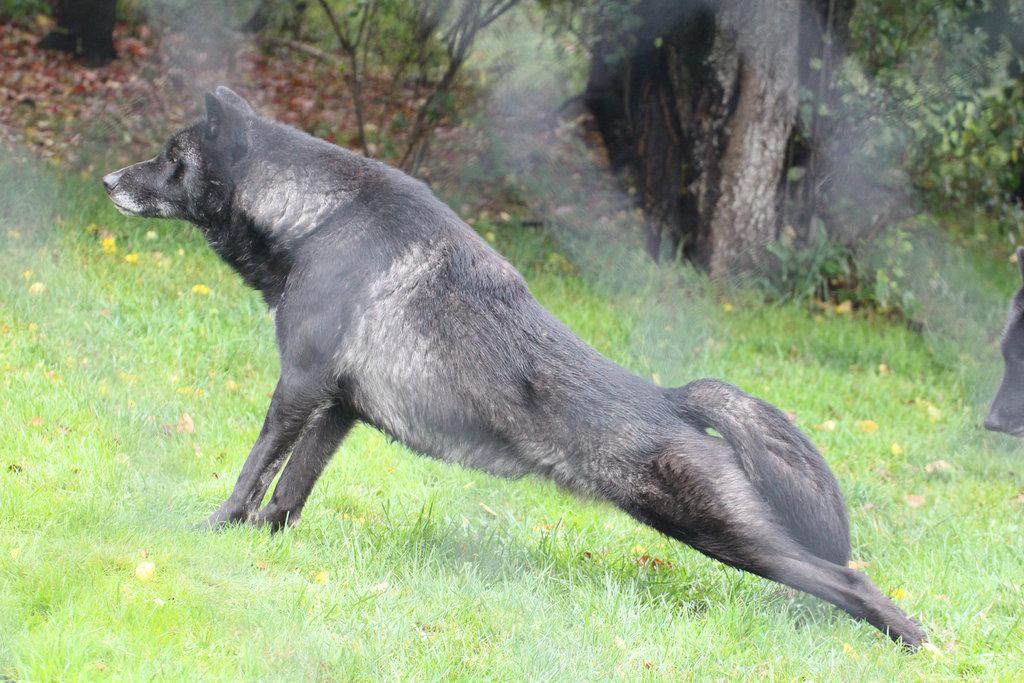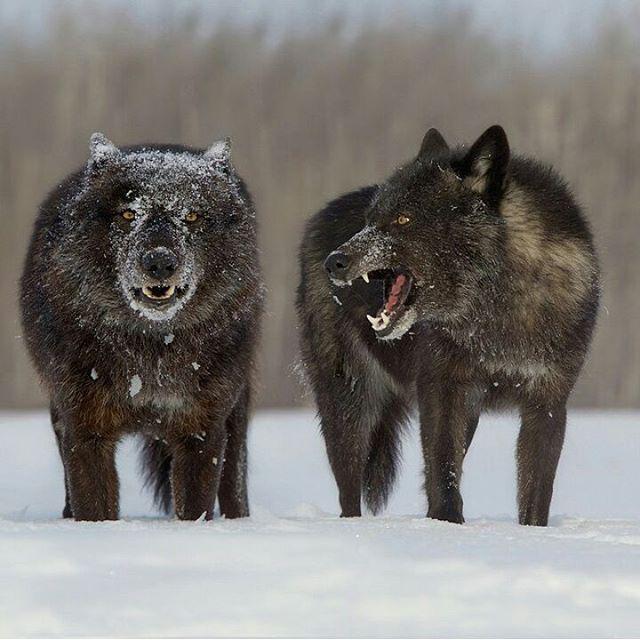The first image is the image on the left, the second image is the image on the right. Evaluate the accuracy of this statement regarding the images: "There is exactly one animal in the image on the right.". Is it true? Answer yes or no. No. 